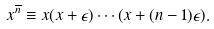Convert formula to latex. <formula><loc_0><loc_0><loc_500><loc_500>x ^ { \overline { n } } \equiv x ( x + \epsilon ) \cdots ( x + ( n - 1 ) \epsilon ) .</formula> 